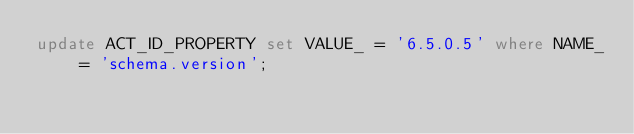<code> <loc_0><loc_0><loc_500><loc_500><_SQL_>update ACT_ID_PROPERTY set VALUE_ = '6.5.0.5' where NAME_ = 'schema.version';
</code> 